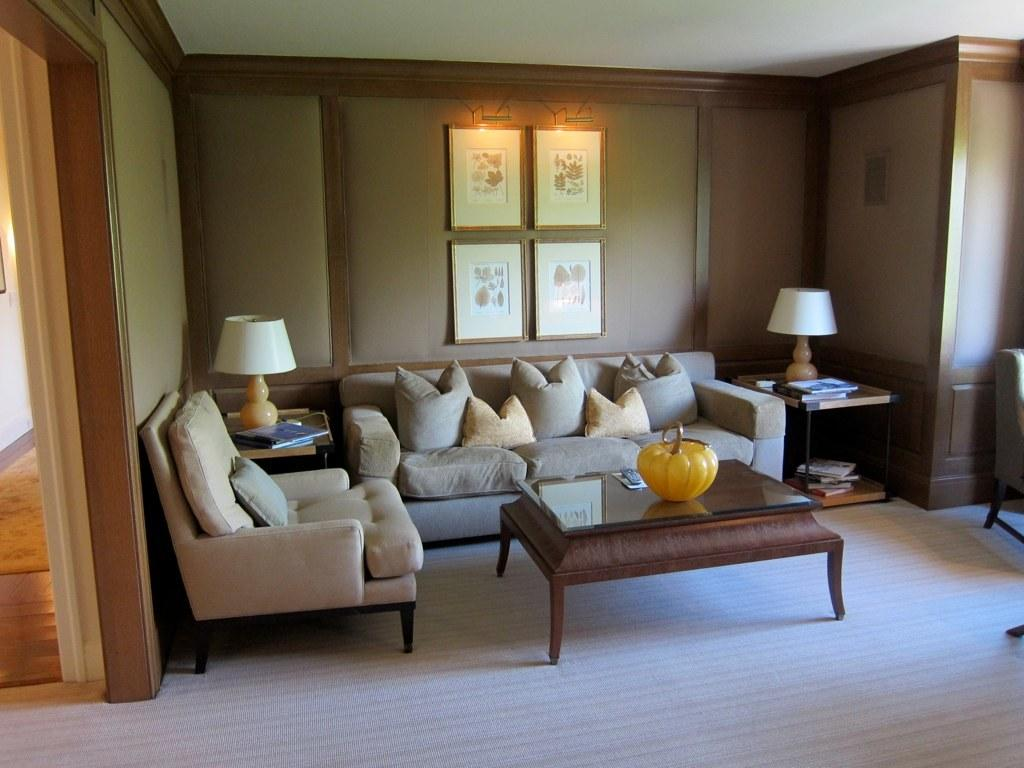What type of room is shown in the image? The image depicts a living room. What furniture is present in the living room? There is a sofa and a table in the living room. How many lamps are in the living room? There are two lamps in the living room. What can be seen on the wall in the living room? There are frames on the wall in the living room. What type of approval is required to enter the living room in the image? There is no mention of any approval required to enter the living room in the image. Can you see any clover plants in the living room? There are no clover plants present in the living room in the image. 